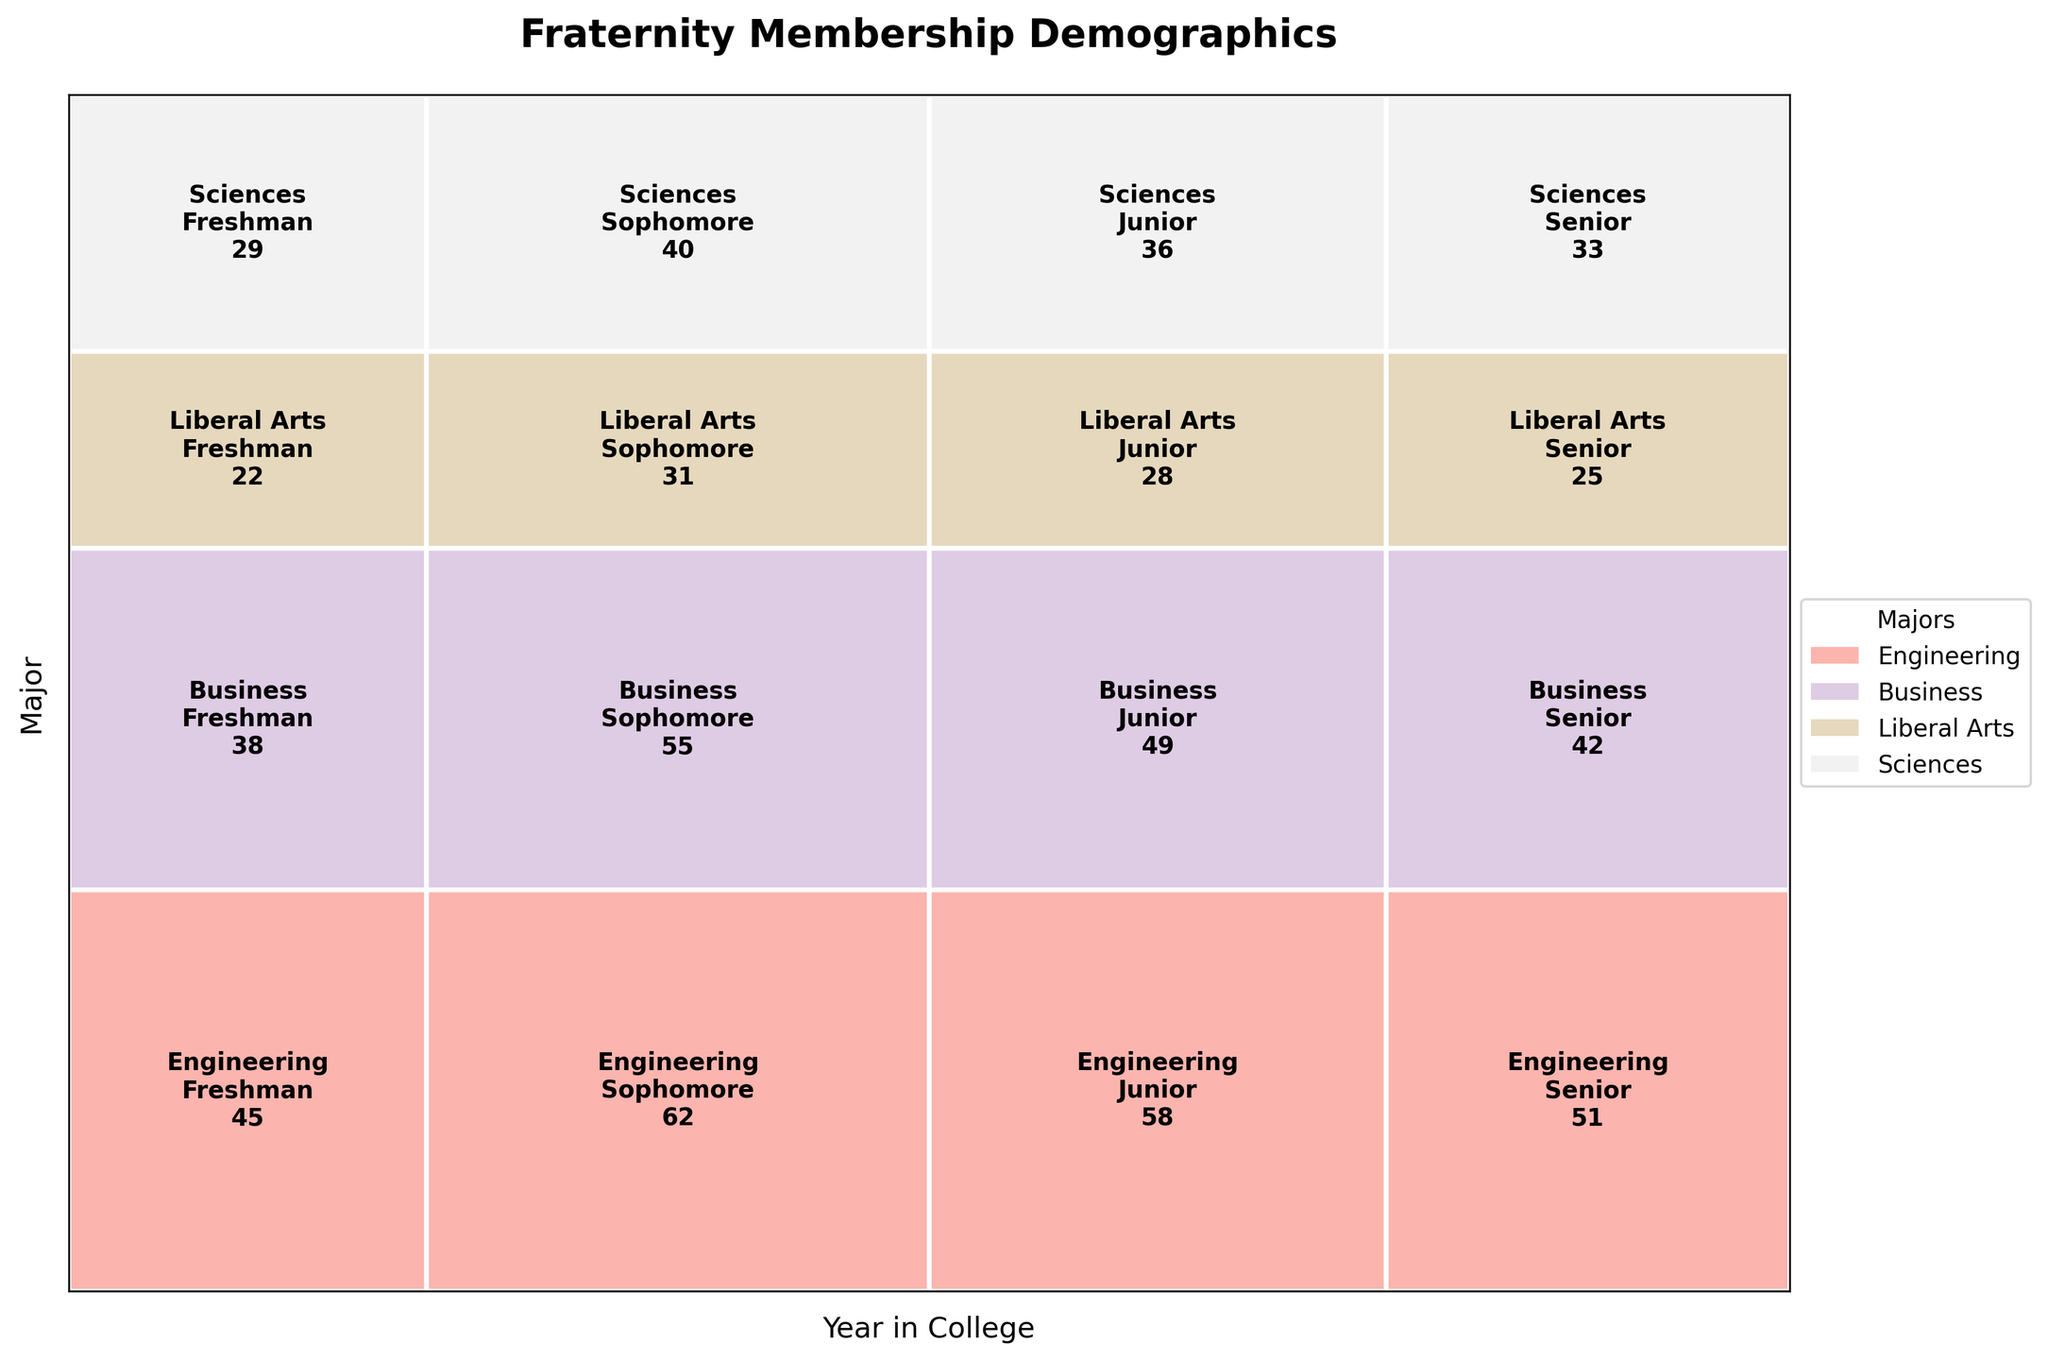What's the most represented year for Engineering majors? Look at the section that represents Engineering majors in the mosaic plot. Identify which year has the largest area. Engineering Sophomores have the largest area, indicating they are the most represented year for Engineering majors.
Answer: Sophomore Which major has the smallest representation in the Freshman year? Compare the widths of all majors in the Freshman year columns. Liberal Arts has the smallest area in the Freshman year section.
Answer: Liberal Arts What is the total fraternity membership for Business majors? Sum the membership values for all years for Business majors (38 + 55 + 49 + 42).
Answer: 184 How do the number of Junior Engineering members compare to Junior Liberal Arts members? Compare the size of the Junior sections between Engineering and Liberal Arts. The number of Junior Engineering members (58) is larger than the number of Junior Liberal Arts members (28).
Answer: Junior Engineering is larger Which year has the largest overall fraternity membership? Compare the overall widths of each year column to determine which year has the largest section. Sophomore year has the largest overall fraternity membership since it has the widest section.
Answer: Sophomore Which major has the most balanced distribution across all years? Look for the major whose sections across all years have roughly similar sizes. Sciences appear to have the most balanced distribution as their sections don't vary significantly in size across years.
Answer: Sciences What's the total membership for Sophomores across all majors? Sum the membership values for all majors for Sophomores (62 + 55 + 31 + 40).
Answer: 188 Which year in college has the smallest membership for Liberal Arts majors? Compare the sizes of the sections for Liberal Arts majors across different years and identify the smallest one. The smallest membership for Liberal Arts majors is in Freshman year.
Answer: Freshman Are Seniors in Business majors more or less than Seniors in Sciences majors? Compare the sizes of the Senior sections for Business and Sciences majors. Seniors in Sciences majors (33) are fewer than Seniors in Business majors (42).
Answer: Business Seniors are more 